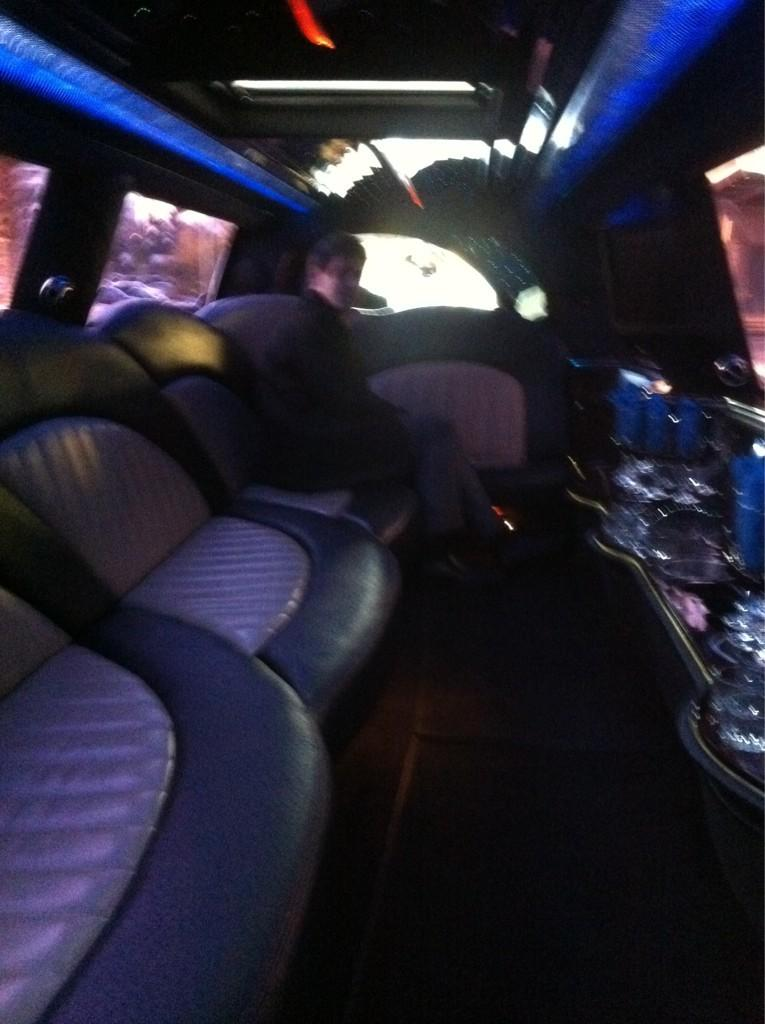What is the person in the image doing? There is a person sitting on a seat in the image. What can be seen on the right side of the side of the image? There is an object on the right side of the image. What allows natural light to enter the space in the image? There are windows in the image. What provides illumination in the space in the image? There are lights attached to the ceiling in the image. What type of caption is written on the object in the image? There is no caption present on the object in the image. How does the acoustics of the space affect the person sitting on the seat? The provided facts do not mention anything about the acoustics of the space, so it cannot be determined how it affects the person sitting on the seat. 